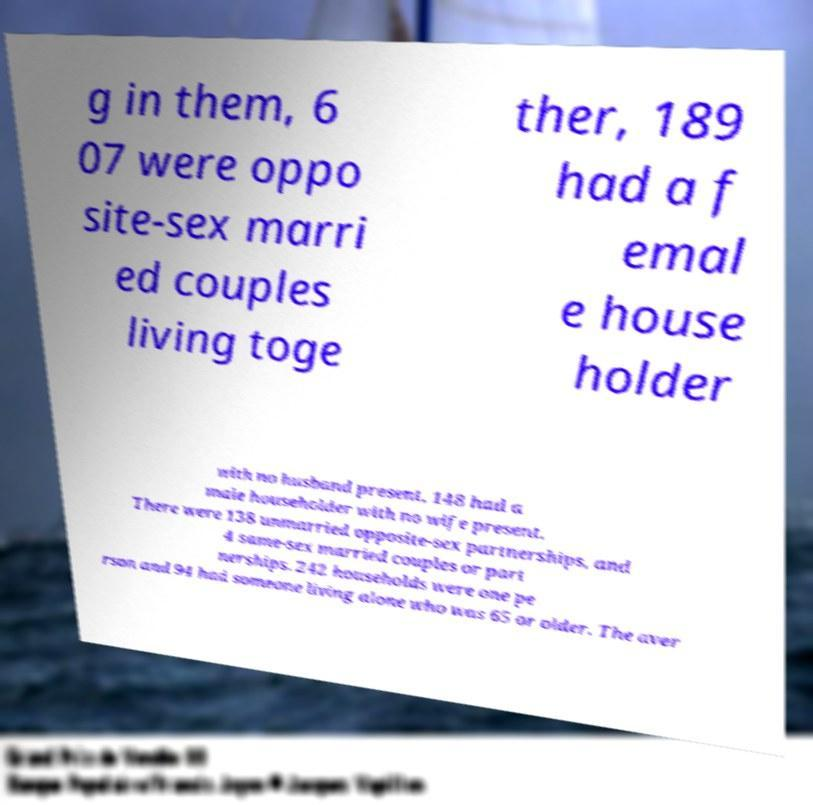Can you accurately transcribe the text from the provided image for me? g in them, 6 07 were oppo site-sex marri ed couples living toge ther, 189 had a f emal e house holder with no husband present, 148 had a male householder with no wife present. There were 138 unmarried opposite-sex partnerships, and 4 same-sex married couples or part nerships. 242 households were one pe rson and 94 had someone living alone who was 65 or older. The aver 